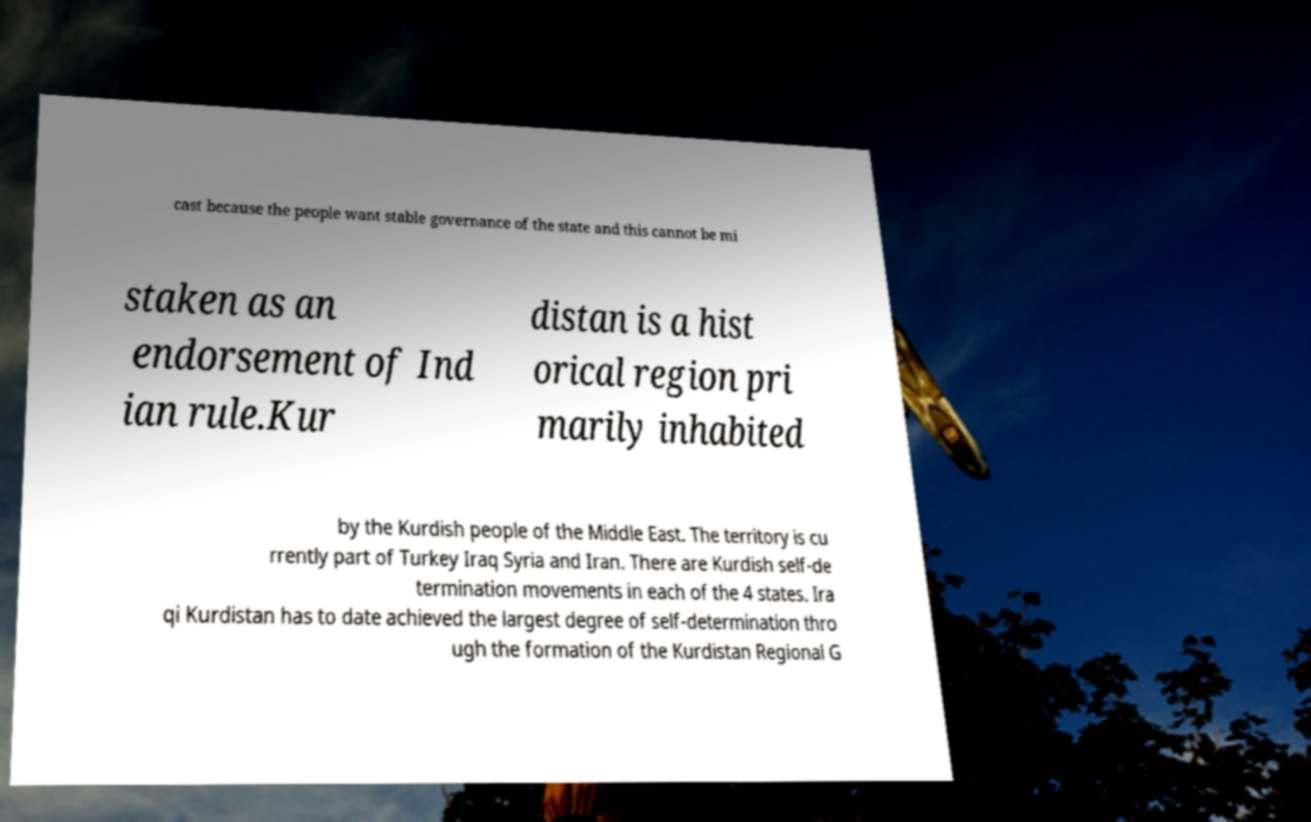Can you accurately transcribe the text from the provided image for me? cast because the people want stable governance of the state and this cannot be mi staken as an endorsement of Ind ian rule.Kur distan is a hist orical region pri marily inhabited by the Kurdish people of the Middle East. The territory is cu rrently part of Turkey Iraq Syria and Iran. There are Kurdish self-de termination movements in each of the 4 states. Ira qi Kurdistan has to date achieved the largest degree of self-determination thro ugh the formation of the Kurdistan Regional G 